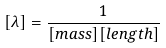Convert formula to latex. <formula><loc_0><loc_0><loc_500><loc_500>[ \lambda ] = \frac { 1 } { [ m a s s ] [ l e n g t h ] }</formula> 